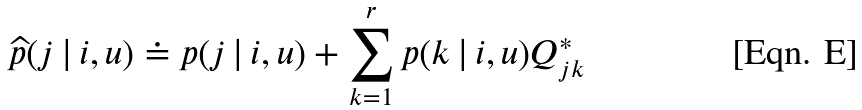<formula> <loc_0><loc_0><loc_500><loc_500>\widehat { p } ( j \, | \, i , u ) \doteq p ( j \, | \, i , u ) + \sum _ { k = 1 } ^ { r } { p ( k \, | \, i , u ) Q ^ { * } _ { j k } }</formula> 